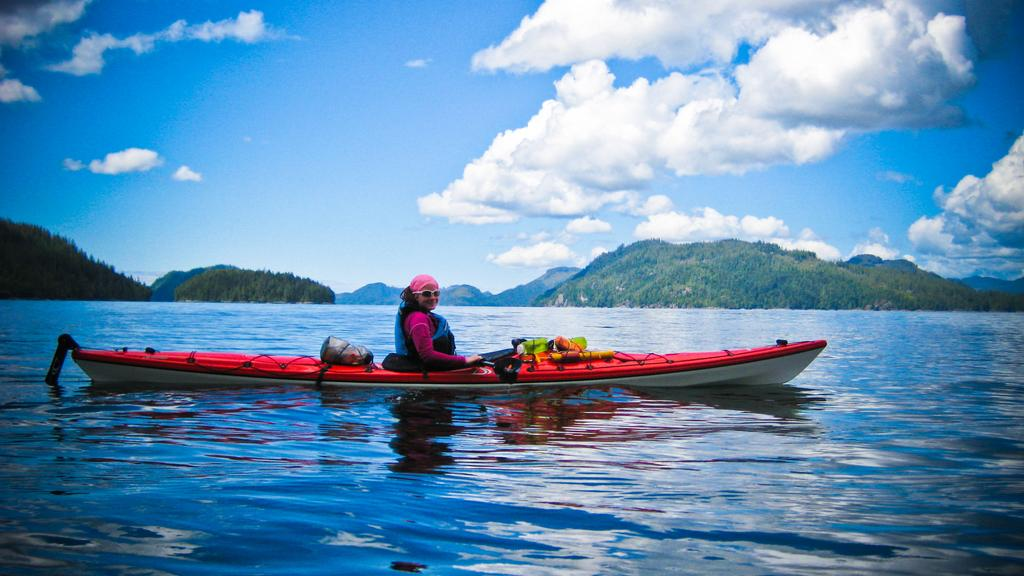What is the person in the image doing? There is a person sitting on a boat in the image. Where is the boat located? The boat is on the water. What type of landscape can be seen in the image? There are trees and hills visible in the image. What is visible in the background of the image? The sky is visible in the background of the image. What year is the judge mentioned in the image? There is no judge mentioned in the image, as it features a person sitting on a boat in a natural setting. 